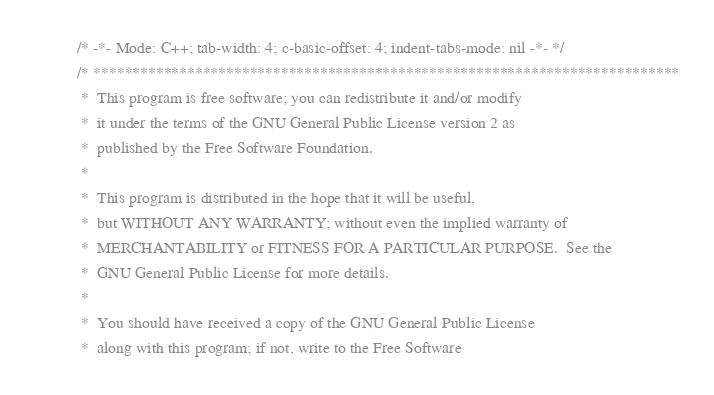Convert code to text. <code><loc_0><loc_0><loc_500><loc_500><_C++_>/* -*- Mode: C++; tab-width: 4; c-basic-offset: 4; indent-tabs-mode: nil -*- */
/* ***************************************************************************
 *  This program is free software; you can redistribute it and/or modify
 *  it under the terms of the GNU General Public License version 2 as 
 *  published by the Free Software Foundation.
 *
 *  This program is distributed in the hope that it will be useful,
 *  but WITHOUT ANY WARRANTY; without even the implied warranty of
 *  MERCHANTABILITY or FITNESS FOR A PARTICULAR PURPOSE.  See the
 *  GNU General Public License for more details.
 *
 *  You should have received a copy of the GNU General Public License
 *  along with this program; if not, write to the Free Software</code> 